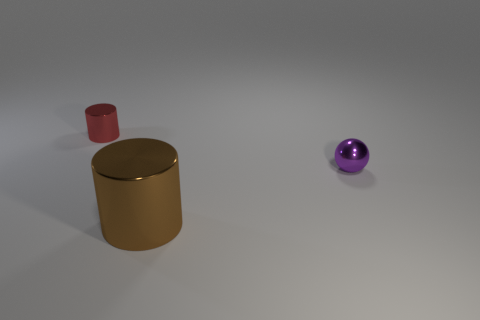Are there any other things that have the same shape as the small purple thing?
Keep it short and to the point. No. There is a tiny cylinder that is made of the same material as the brown object; what color is it?
Ensure brevity in your answer.  Red. How many objects have the same size as the purple metal ball?
Keep it short and to the point. 1. What number of gray things are tiny metal cylinders or rubber objects?
Provide a short and direct response. 0. How many things are tiny cylinders or metal objects to the right of the tiny cylinder?
Provide a succinct answer. 3. What is the material of the cylinder that is in front of the tiny ball?
Your answer should be very brief. Metal. What shape is the purple shiny object that is the same size as the red shiny thing?
Your answer should be compact. Sphere. Are there any other tiny objects of the same shape as the purple object?
Provide a succinct answer. No. Are the small cylinder and the tiny purple sphere that is on the right side of the large cylinder made of the same material?
Give a very brief answer. Yes. There is a tiny thing in front of the small metal object that is to the left of the big brown object; what is its material?
Offer a terse response. Metal. 